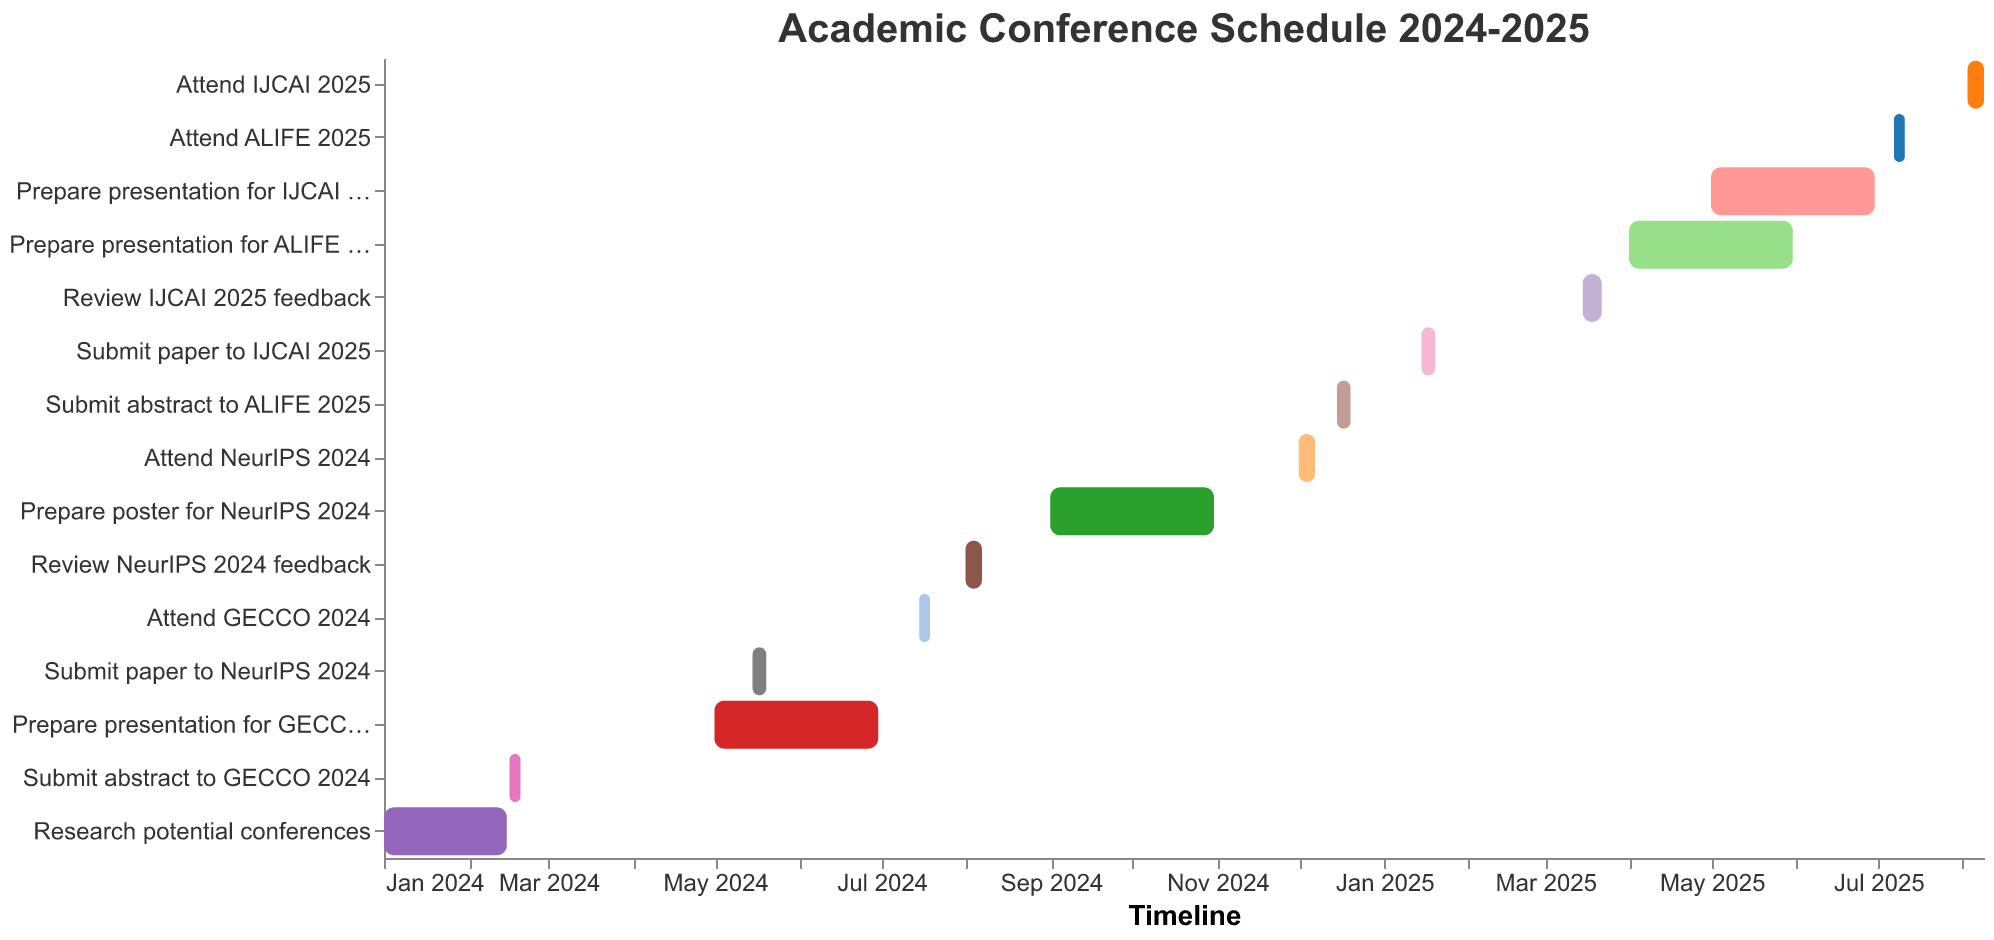What is the start date for the task "Research potential conferences"? The Gantt chart visually shows tasks along a timeline. Locate "Research potential conferences" on the y-axis, then follow it horizontally to the start date.
Answer: January 1, 2024 What are the start and end dates for attending GECCO 2024? Locate "Attend GECCO 2024" on the y-axis of the Gantt chart and follow it horizontally to find the start and end dates.
Answer: Start: July 15, 2024, End: July 19, 2024 Which task has the longest duration? Compare the lengths of the bars representing each task on the Gantt chart. The bar that extends the furthest across the timeline indicates the longest task.
Answer: Prepare poster for NeurIPS 2024 How does the preparation time for GECCO 2024 compare to NeurIPS 2024? Identify the tasks "Prepare presentation for GECCO 2024" and "Prepare poster for NeurIPS 2024" on the y-axis, then compare the lengths of their bars to see which one is longer.
Answer: GECCO 2024 preparation is shorter than NeurIPS 2024 How many days are scheduled between the end of attending NeurIPS 2024 and the start of preparing for ALIFE 2025? Determine the end date for "Attend NeurIPS 2024" and the start date for "Prepare presentation for ALIFE 2025," then calculate the difference in days.
Answer: 84 days Which conference task is scheduled closest to submitting an abstract for ALIFE 2025? Locate "Submit abstract to ALIFE 2025" on the timeline, then identify the task closest to it before or after.
Answer: Attend NeurIPS 2024 What is the duration between the submission of the IJCAI 2025 paper and the review of IJCAI 2025 feedback? Identify the end date for "Submit paper to IJCAI 2025" and the start date for "Review IJCAI 2025 feedback," then calculate the difference in days.
Answer: 54 days Do any tasks overlap in June 2024? Observe the timeline for June 2024 on the x-axis and see if any bars representing different tasks overlap during this period.
Answer: Yes, Prepare presentation for GECCO 2024 and Submit paper to NeurIPS 2024 overlap What is the last task scheduled in 2024? Observe the tasks and their endpoints on the Gantt chart, focusing on the end of the timeline in 2024. The task that ends last is the one we're looking for.
Answer: Submit abstract to ALIFE 2025 How many academic conferences are attended according to the schedule? Count the number of tasks that start with "Attend" on the y-axis of the Gantt chart.
Answer: Four 